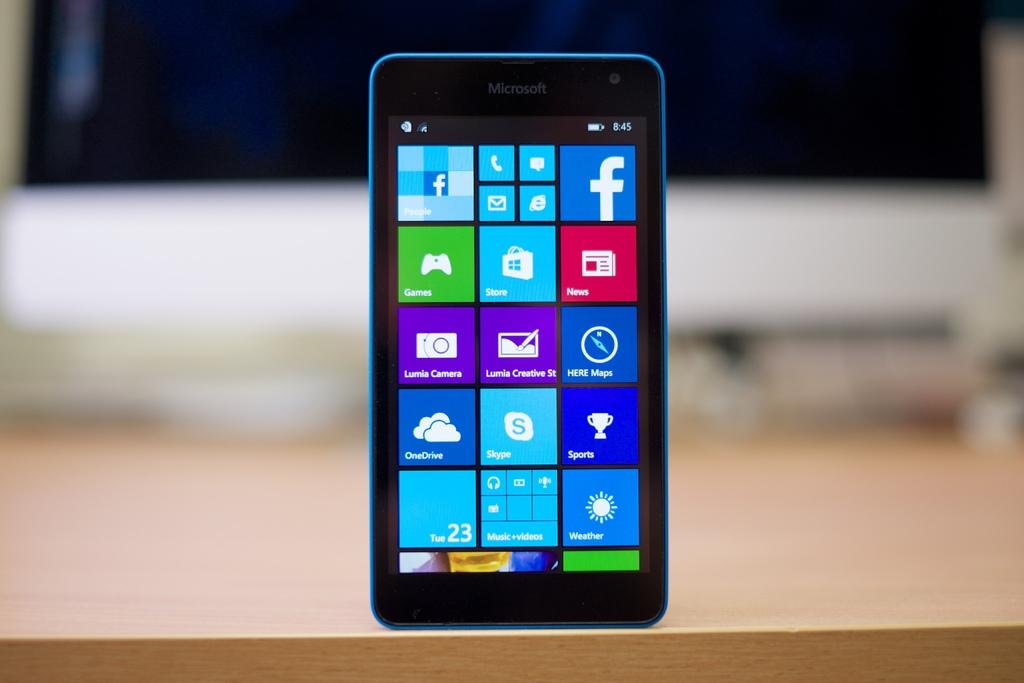Provide a one-sentence caption for the provided image. A blue phone from the Microsoft brand is on the table. 